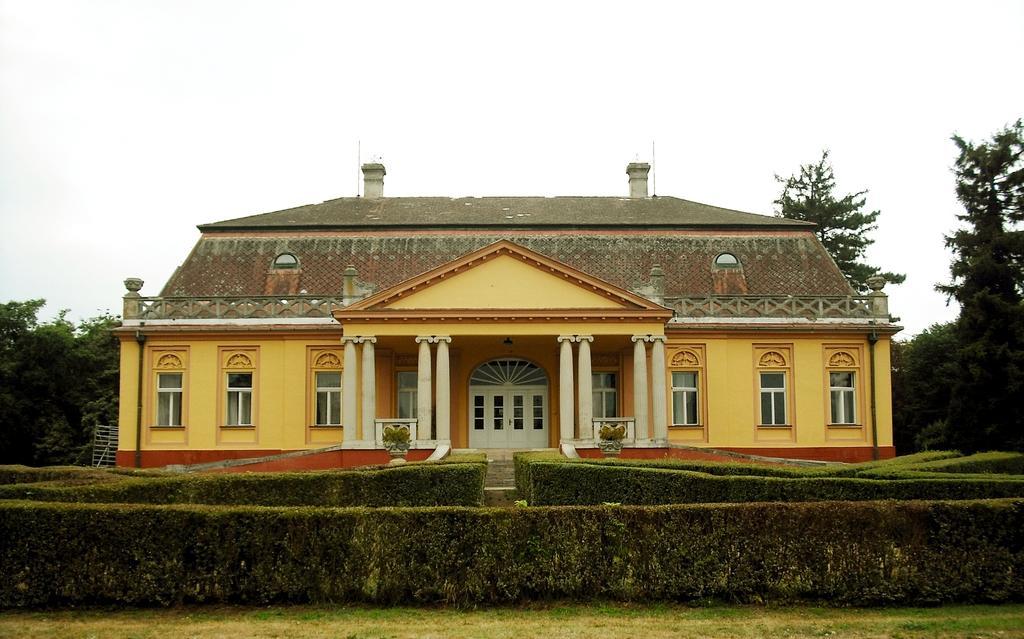Describe this image in one or two sentences. In this image there is a house. In front of the house there are hedges. At the bottom there is grass on the ground. Behind the house there are trees. At the top there is the sky. 